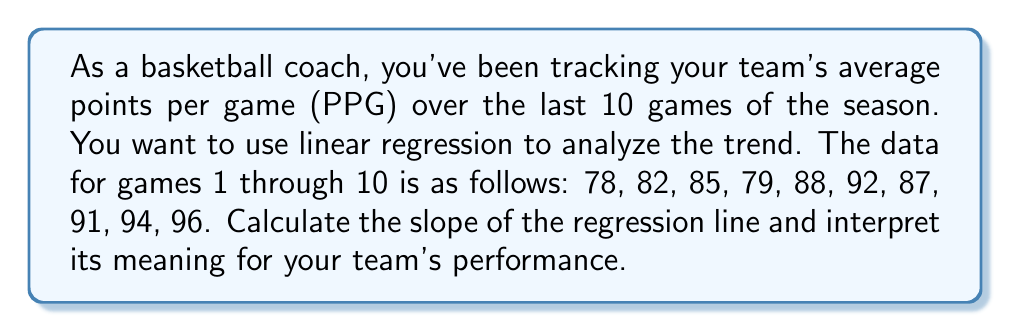Can you solve this math problem? Let's approach this step-by-step:

1) First, we need to set up our data. Let $x$ be the game number and $y$ be the PPG.

2) To calculate the slope, we'll use the formula:

   $$m = \frac{n\sum xy - \sum x \sum y}{n\sum x^2 - (\sum x)^2}$$

   Where $n$ is the number of data points (10 in this case).

3) Let's calculate the necessary sums:

   $\sum x = 1 + 2 + 3 + ... + 10 = 55$
   $\sum y = 78 + 82 + 85 + ... + 96 = 872$
   $\sum xy = 1(78) + 2(82) + 3(85) + ... + 10(96) = 8,514$
   $\sum x^2 = 1^2 + 2^2 + 3^2 + ... + 10^2 = 385$

4) Now, let's plug these values into our slope formula:

   $$m = \frac{10(8,514) - 55(872)}{10(385) - 55^2}$$

5) Simplifying:

   $$m = \frac{85,140 - 47,960}{3,850 - 3,025} = \frac{37,180}{825} = 45.0667$$

6) Rounding to two decimal places, we get a slope of 2.18.

7) Interpretation: The slope represents the average increase in points per game over the course of these 10 games. A positive slope of 2.18 indicates that, on average, the team's score is increasing by 2.18 points each game.
Answer: 2.18 points per game increase 